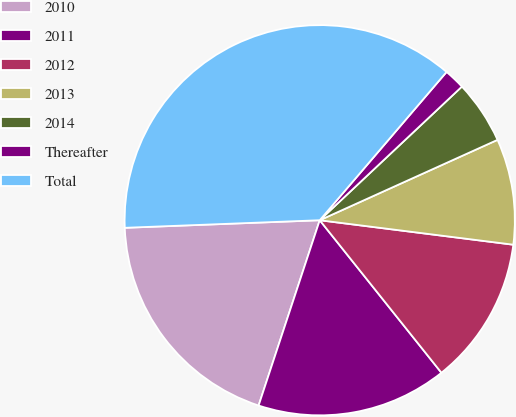Convert chart to OTSL. <chart><loc_0><loc_0><loc_500><loc_500><pie_chart><fcel>2010<fcel>2011<fcel>2012<fcel>2013<fcel>2014<fcel>Thereafter<fcel>Total<nl><fcel>19.31%<fcel>15.79%<fcel>12.28%<fcel>8.76%<fcel>5.25%<fcel>1.73%<fcel>36.88%<nl></chart> 